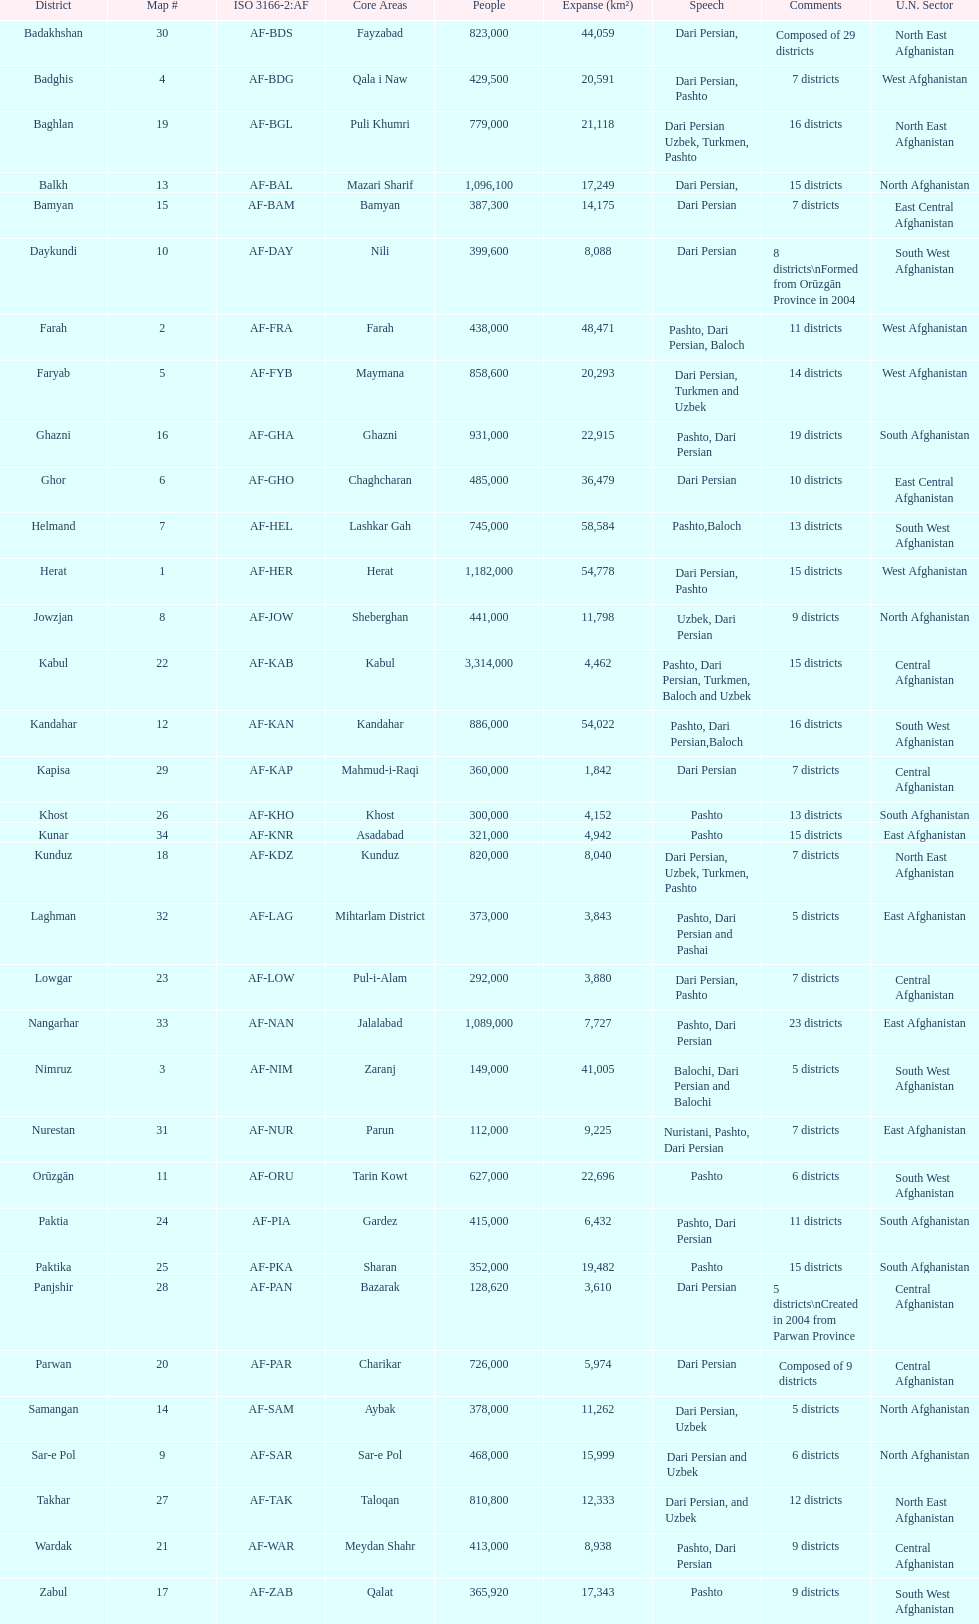How many provinces have the same number of districts as kabul? 4. Can you give me this table as a dict? {'header': ['District', 'Map #', 'ISO 3166-2:AF', 'Core Areas', 'People', 'Expanse (km²)', 'Speech', 'Comments', 'U.N. Sector'], 'rows': [['Badakhshan', '30', 'AF-BDS', 'Fayzabad', '823,000', '44,059', 'Dari Persian,', 'Composed of 29 districts', 'North East Afghanistan'], ['Badghis', '4', 'AF-BDG', 'Qala i Naw', '429,500', '20,591', 'Dari Persian, Pashto', '7 districts', 'West Afghanistan'], ['Baghlan', '19', 'AF-BGL', 'Puli Khumri', '779,000', '21,118', 'Dari Persian Uzbek, Turkmen, Pashto', '16 districts', 'North East Afghanistan'], ['Balkh', '13', 'AF-BAL', 'Mazari Sharif', '1,096,100', '17,249', 'Dari Persian,', '15 districts', 'North Afghanistan'], ['Bamyan', '15', 'AF-BAM', 'Bamyan', '387,300', '14,175', 'Dari Persian', '7 districts', 'East Central Afghanistan'], ['Daykundi', '10', 'AF-DAY', 'Nili', '399,600', '8,088', 'Dari Persian', '8 districts\\nFormed from Orūzgān Province in 2004', 'South West Afghanistan'], ['Farah', '2', 'AF-FRA', 'Farah', '438,000', '48,471', 'Pashto, Dari Persian, Baloch', '11 districts', 'West Afghanistan'], ['Faryab', '5', 'AF-FYB', 'Maymana', '858,600', '20,293', 'Dari Persian, Turkmen and Uzbek', '14 districts', 'West Afghanistan'], ['Ghazni', '16', 'AF-GHA', 'Ghazni', '931,000', '22,915', 'Pashto, Dari Persian', '19 districts', 'South Afghanistan'], ['Ghor', '6', 'AF-GHO', 'Chaghcharan', '485,000', '36,479', 'Dari Persian', '10 districts', 'East Central Afghanistan'], ['Helmand', '7', 'AF-HEL', 'Lashkar Gah', '745,000', '58,584', 'Pashto,Baloch', '13 districts', 'South West Afghanistan'], ['Herat', '1', 'AF-HER', 'Herat', '1,182,000', '54,778', 'Dari Persian, Pashto', '15 districts', 'West Afghanistan'], ['Jowzjan', '8', 'AF-JOW', 'Sheberghan', '441,000', '11,798', 'Uzbek, Dari Persian', '9 districts', 'North Afghanistan'], ['Kabul', '22', 'AF-KAB', 'Kabul', '3,314,000', '4,462', 'Pashto, Dari Persian, Turkmen, Baloch and Uzbek', '15 districts', 'Central Afghanistan'], ['Kandahar', '12', 'AF-KAN', 'Kandahar', '886,000', '54,022', 'Pashto, Dari Persian,Baloch', '16 districts', 'South West Afghanistan'], ['Kapisa', '29', 'AF-KAP', 'Mahmud-i-Raqi', '360,000', '1,842', 'Dari Persian', '7 districts', 'Central Afghanistan'], ['Khost', '26', 'AF-KHO', 'Khost', '300,000', '4,152', 'Pashto', '13 districts', 'South Afghanistan'], ['Kunar', '34', 'AF-KNR', 'Asadabad', '321,000', '4,942', 'Pashto', '15 districts', 'East Afghanistan'], ['Kunduz', '18', 'AF-KDZ', 'Kunduz', '820,000', '8,040', 'Dari Persian, Uzbek, Turkmen, Pashto', '7 districts', 'North East Afghanistan'], ['Laghman', '32', 'AF-LAG', 'Mihtarlam District', '373,000', '3,843', 'Pashto, Dari Persian and Pashai', '5 districts', 'East Afghanistan'], ['Lowgar', '23', 'AF-LOW', 'Pul-i-Alam', '292,000', '3,880', 'Dari Persian, Pashto', '7 districts', 'Central Afghanistan'], ['Nangarhar', '33', 'AF-NAN', 'Jalalabad', '1,089,000', '7,727', 'Pashto, Dari Persian', '23 districts', 'East Afghanistan'], ['Nimruz', '3', 'AF-NIM', 'Zaranj', '149,000', '41,005', 'Balochi, Dari Persian and Balochi', '5 districts', 'South West Afghanistan'], ['Nurestan', '31', 'AF-NUR', 'Parun', '112,000', '9,225', 'Nuristani, Pashto, Dari Persian', '7 districts', 'East Afghanistan'], ['Orūzgān', '11', 'AF-ORU', 'Tarin Kowt', '627,000', '22,696', 'Pashto', '6 districts', 'South West Afghanistan'], ['Paktia', '24', 'AF-PIA', 'Gardez', '415,000', '6,432', 'Pashto, Dari Persian', '11 districts', 'South Afghanistan'], ['Paktika', '25', 'AF-PKA', 'Sharan', '352,000', '19,482', 'Pashto', '15 districts', 'South Afghanistan'], ['Panjshir', '28', 'AF-PAN', 'Bazarak', '128,620', '3,610', 'Dari Persian', '5 districts\\nCreated in 2004 from Parwan Province', 'Central Afghanistan'], ['Parwan', '20', 'AF-PAR', 'Charikar', '726,000', '5,974', 'Dari Persian', 'Composed of 9 districts', 'Central Afghanistan'], ['Samangan', '14', 'AF-SAM', 'Aybak', '378,000', '11,262', 'Dari Persian, Uzbek', '5 districts', 'North Afghanistan'], ['Sar-e Pol', '9', 'AF-SAR', 'Sar-e Pol', '468,000', '15,999', 'Dari Persian and Uzbek', '6 districts', 'North Afghanistan'], ['Takhar', '27', 'AF-TAK', 'Taloqan', '810,800', '12,333', 'Dari Persian, and Uzbek', '12 districts', 'North East Afghanistan'], ['Wardak', '21', 'AF-WAR', 'Meydan Shahr', '413,000', '8,938', 'Pashto, Dari Persian', '9 districts', 'Central Afghanistan'], ['Zabul', '17', 'AF-ZAB', 'Qalat', '365,920', '17,343', 'Pashto', '9 districts', 'South West Afghanistan']]} 